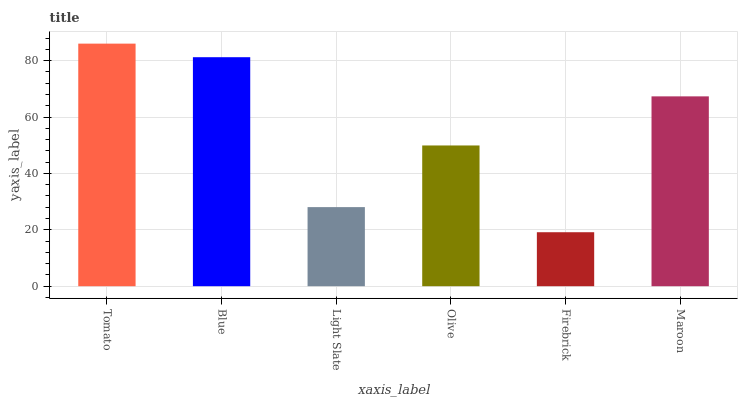Is Firebrick the minimum?
Answer yes or no. Yes. Is Tomato the maximum?
Answer yes or no. Yes. Is Blue the minimum?
Answer yes or no. No. Is Blue the maximum?
Answer yes or no. No. Is Tomato greater than Blue?
Answer yes or no. Yes. Is Blue less than Tomato?
Answer yes or no. Yes. Is Blue greater than Tomato?
Answer yes or no. No. Is Tomato less than Blue?
Answer yes or no. No. Is Maroon the high median?
Answer yes or no. Yes. Is Olive the low median?
Answer yes or no. Yes. Is Firebrick the high median?
Answer yes or no. No. Is Light Slate the low median?
Answer yes or no. No. 